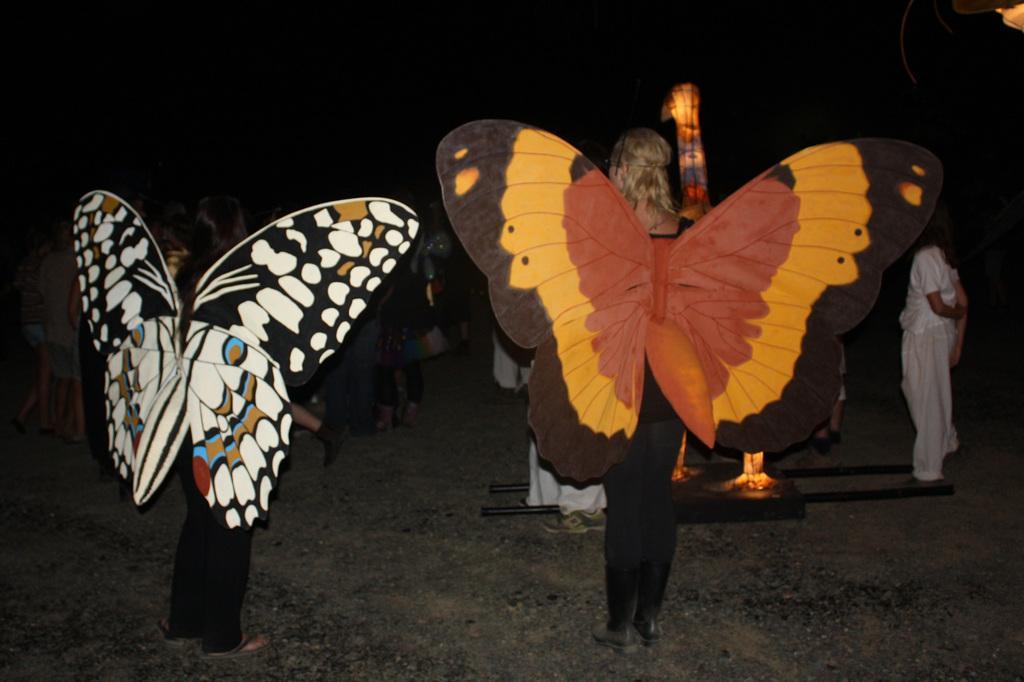In one or two sentences, can you explain what this image depicts? In this image there are group of people standing on the ground, in which some of them are wearing butterfly wings. 